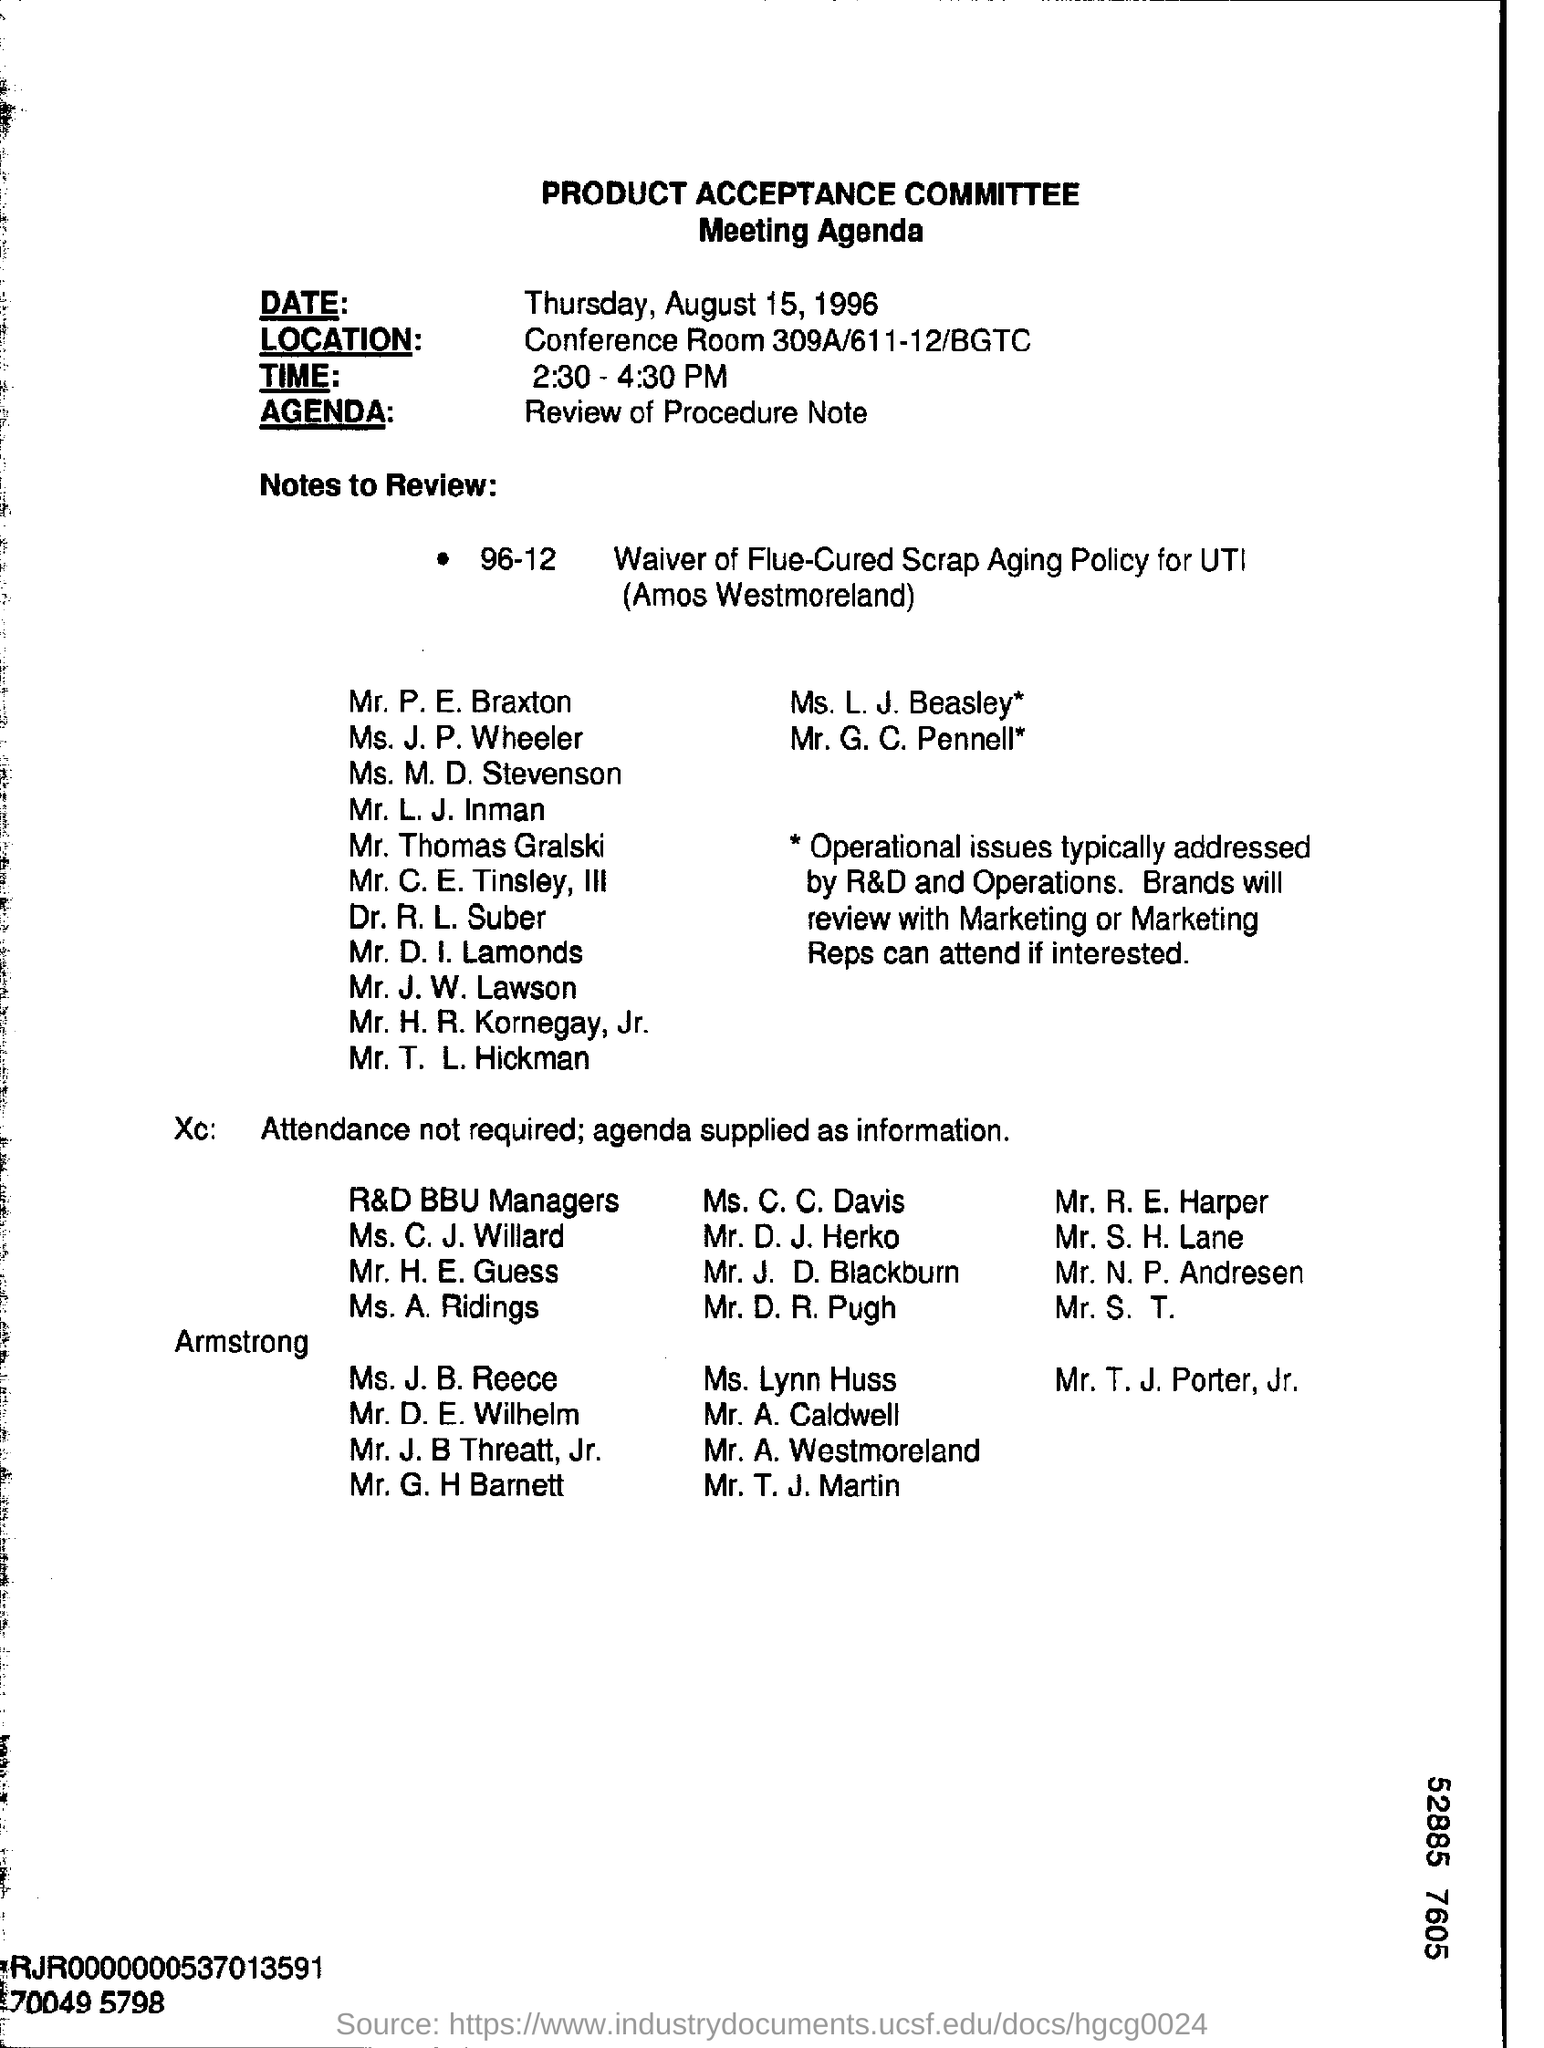What is the name of the committee?
Ensure brevity in your answer.  PRODUCT ACCEPTANCE COMMITTEE. Where is the location of the meeting?
Your response must be concise. Conference room 309a/611-12/bgtc. What is the agenda of the meeting?
Your answer should be very brief. Review of procedure note. 